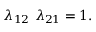Convert formula to latex. <formula><loc_0><loc_0><loc_500><loc_500>\lambda _ { 1 2 } \ \lambda _ { 2 1 } = 1 .</formula> 